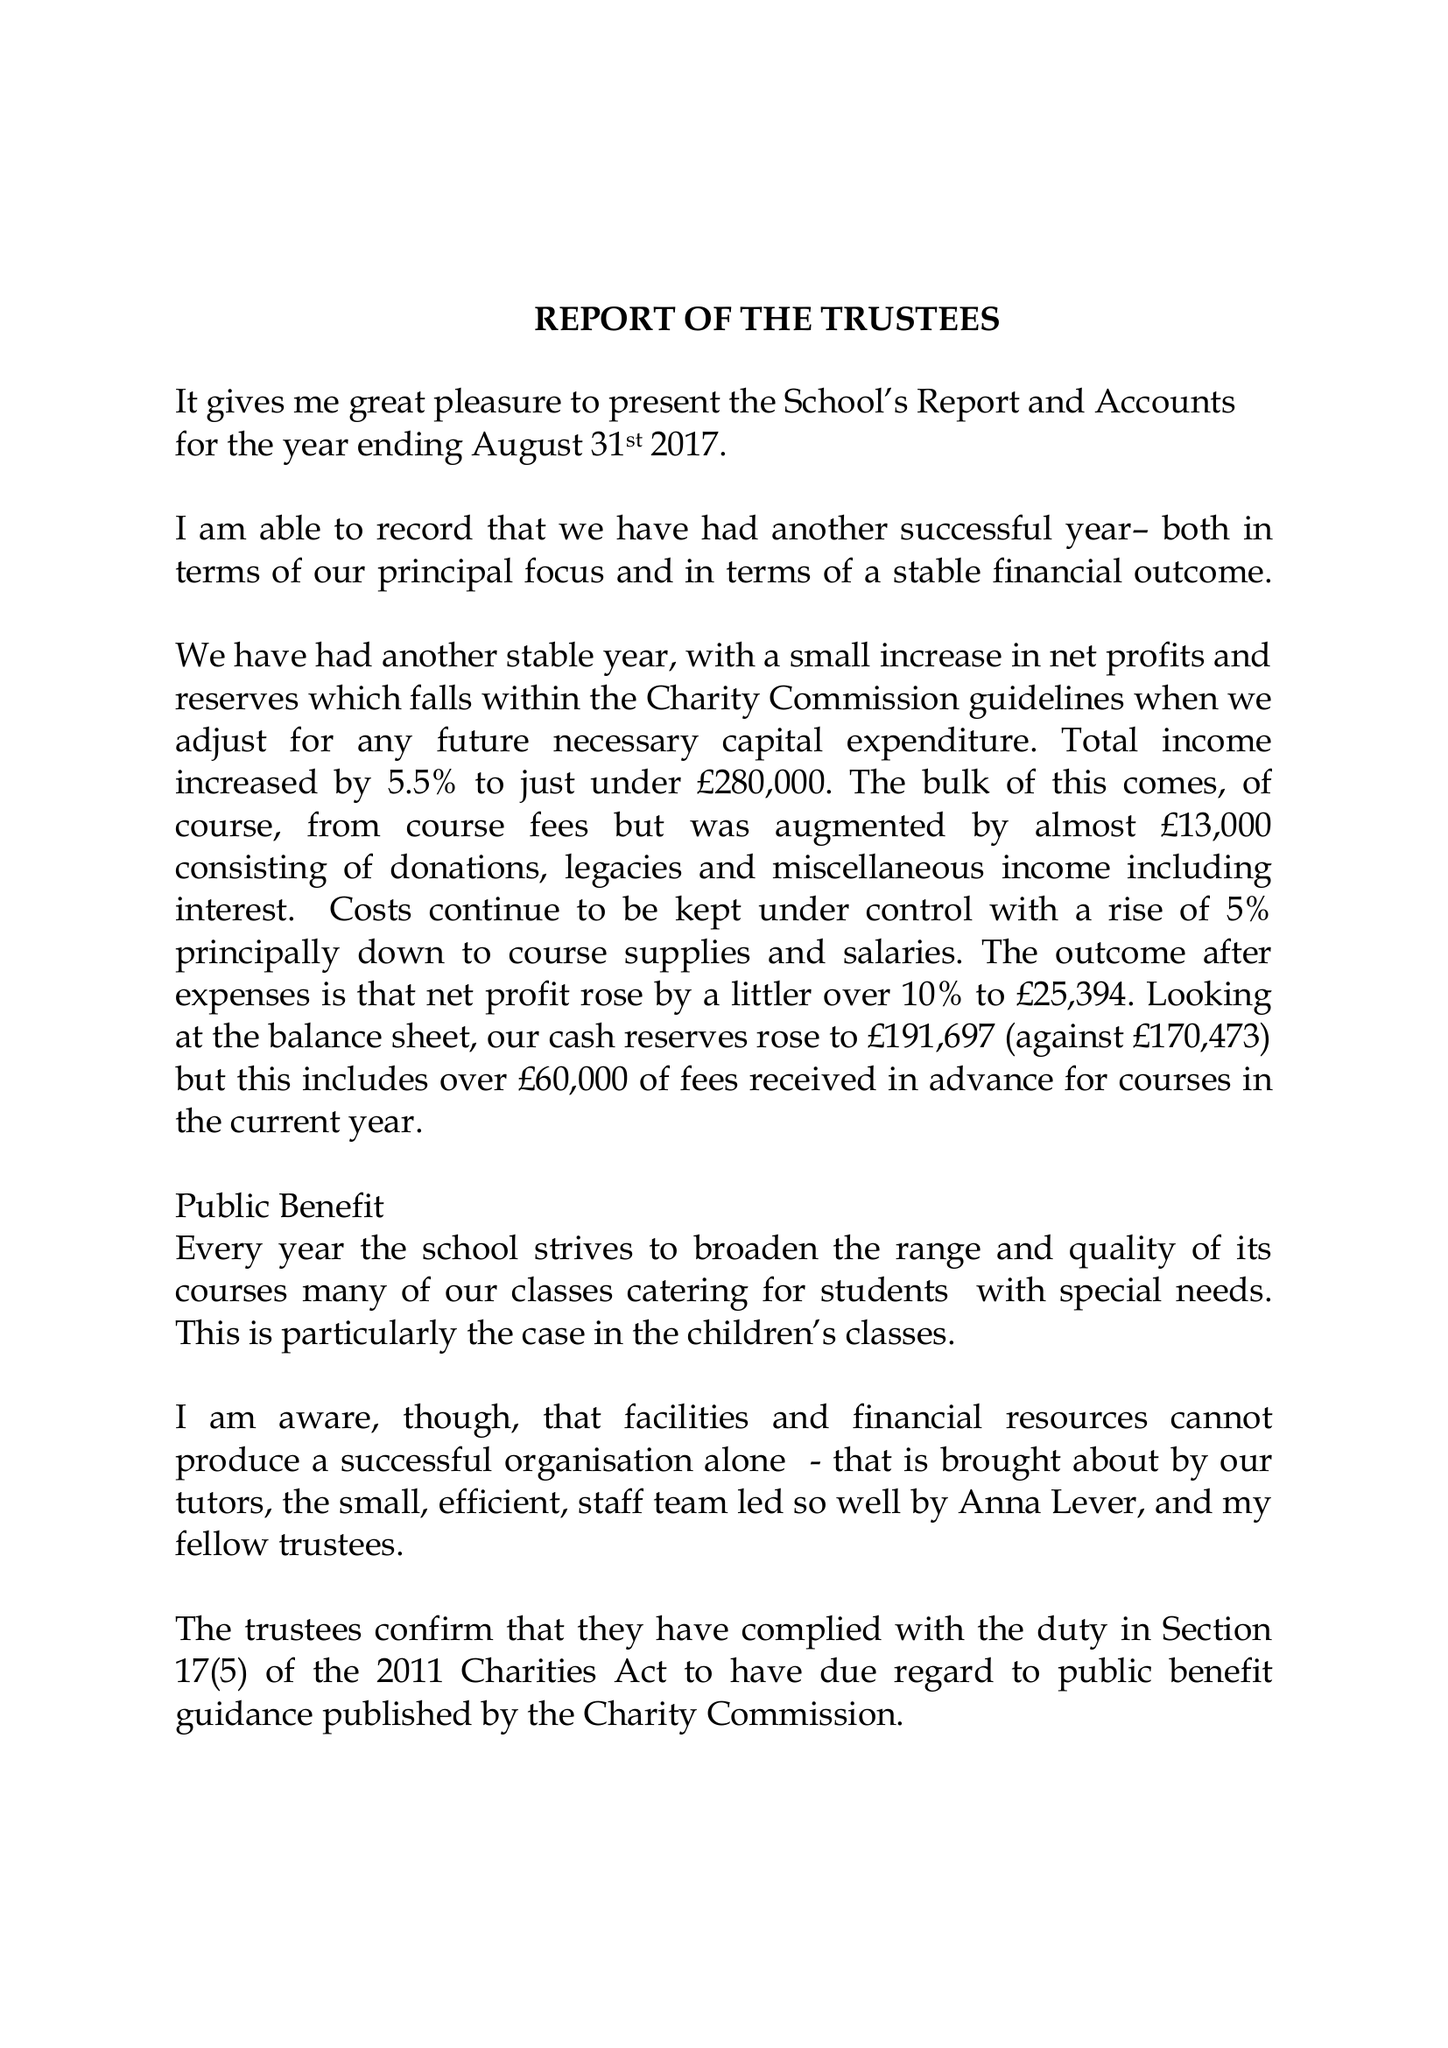What is the value for the report_date?
Answer the question using a single word or phrase. 2017-08-31 